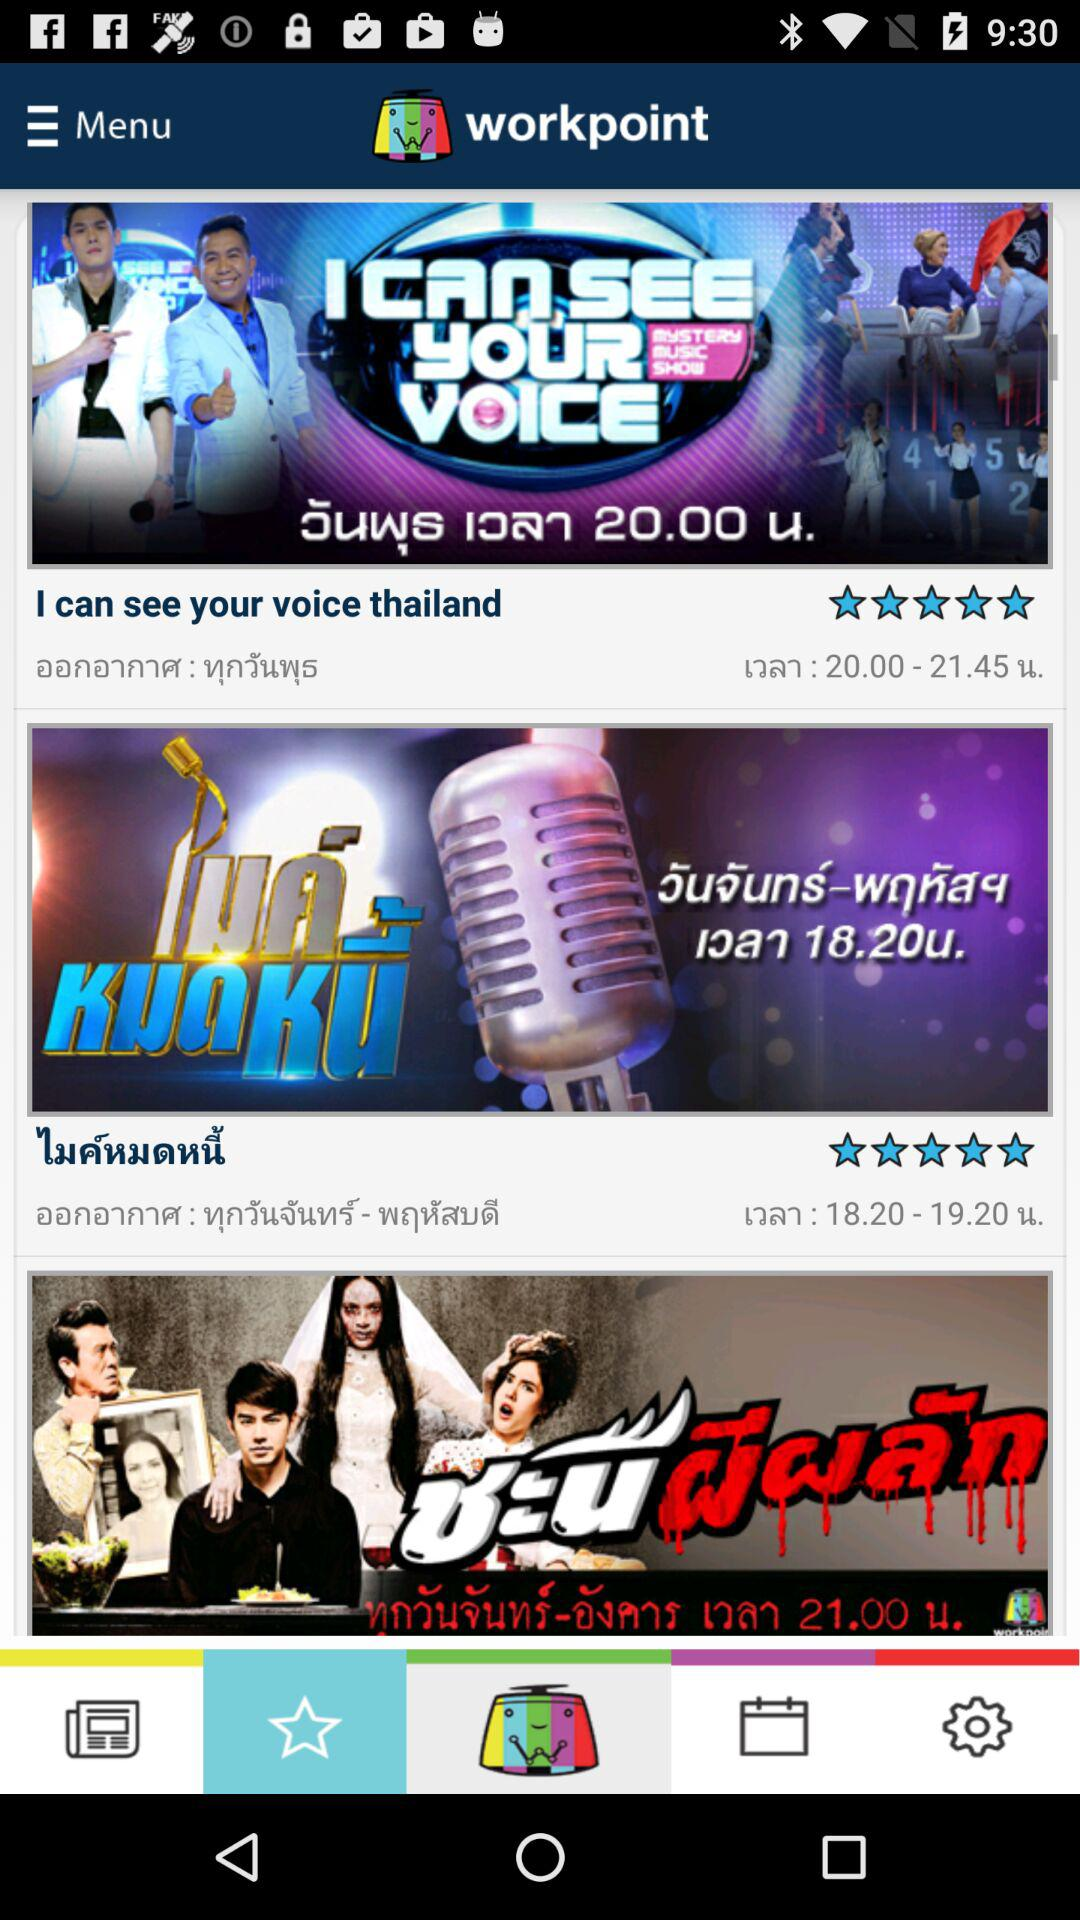What is the name of the application? The name of the application is "workpoint". 